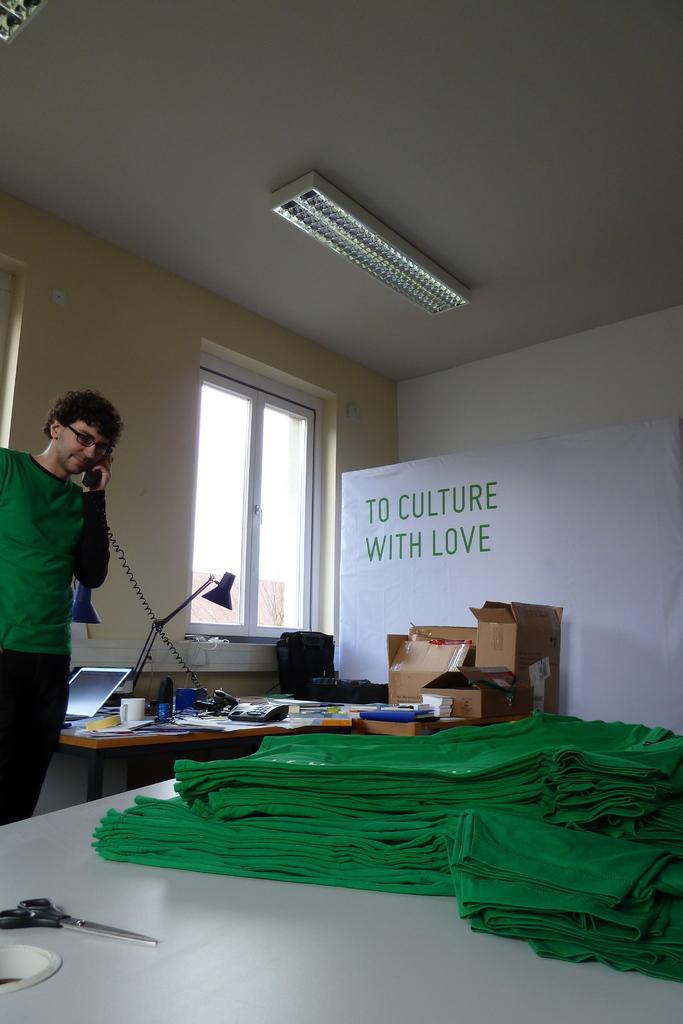Can you describe this image briefly? In this picture we can see a man wore a spectacle and holding a phone with his hand and standing and in front of him on tables we can see clothes, scissor, lamp, laptop, cup and some objects and in the background we can see boxes, wall, window. 